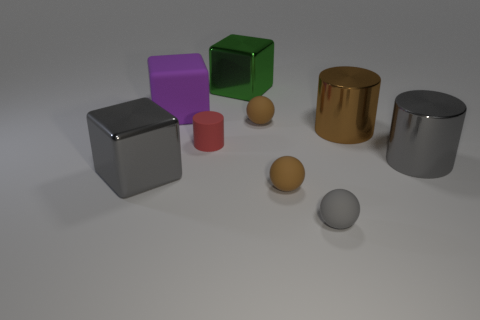Are there more large rubber objects that are left of the large gray cube than small blue metallic cubes?
Ensure brevity in your answer.  No. Do the purple matte object and the gray rubber sphere have the same size?
Keep it short and to the point. No. There is a cylinder that is made of the same material as the large purple thing; what color is it?
Your answer should be very brief. Red. Are there an equal number of gray balls that are in front of the big gray cylinder and green metallic blocks that are behind the purple rubber thing?
Provide a short and direct response. Yes. There is a brown thing in front of the big gray shiny object on the right side of the large gray metallic cube; what shape is it?
Give a very brief answer. Sphere. What material is the brown object that is the same shape as the small red rubber object?
Keep it short and to the point. Metal. What color is the rubber thing that is the same size as the green metal block?
Give a very brief answer. Purple. Are there the same number of big purple things that are right of the large purple rubber cube and small red rubber cylinders?
Provide a succinct answer. No. The large cylinder behind the big cylinder in front of the red matte cylinder is what color?
Your answer should be compact. Brown. There is a metallic block left of the block behind the large matte thing; how big is it?
Provide a succinct answer. Large. 